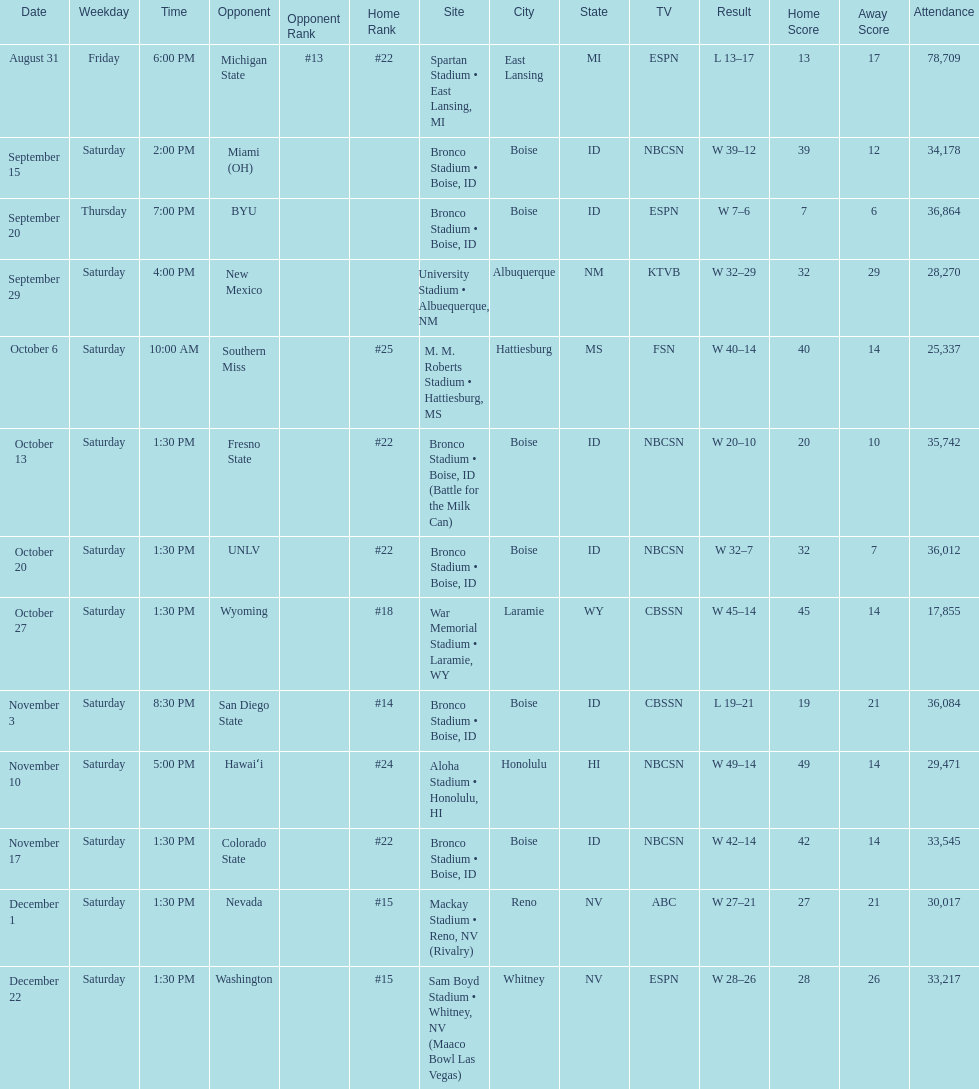Which team has the highest rank among those listed? San Diego State. 